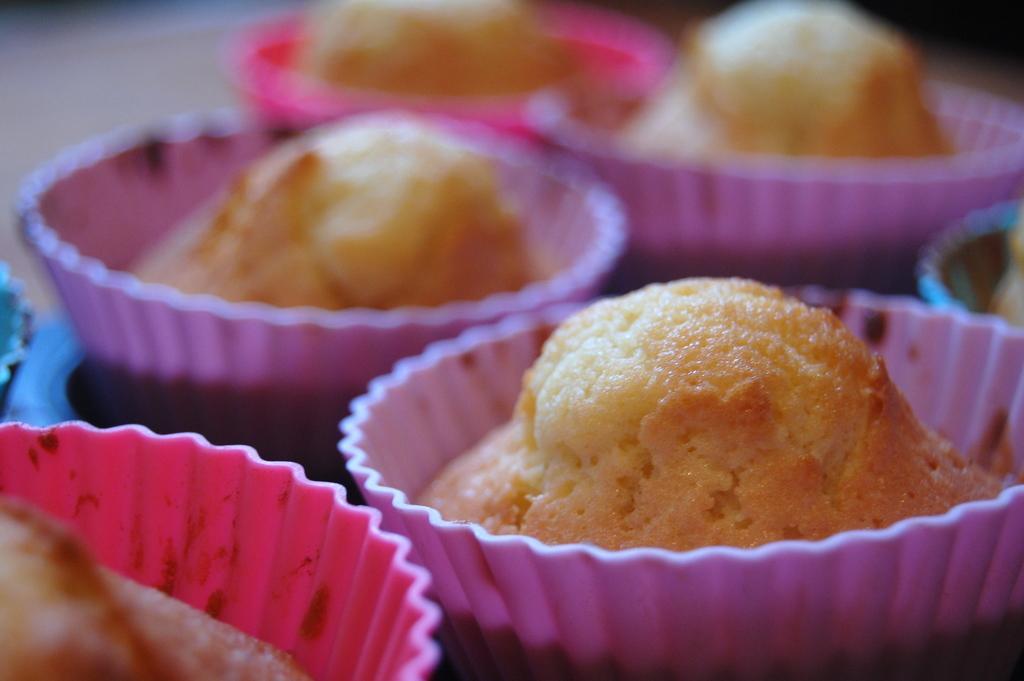Can you describe this image briefly? In this image I can see few cups which are pink in color and in them I can see cupcakes which are cream and brown in color. 